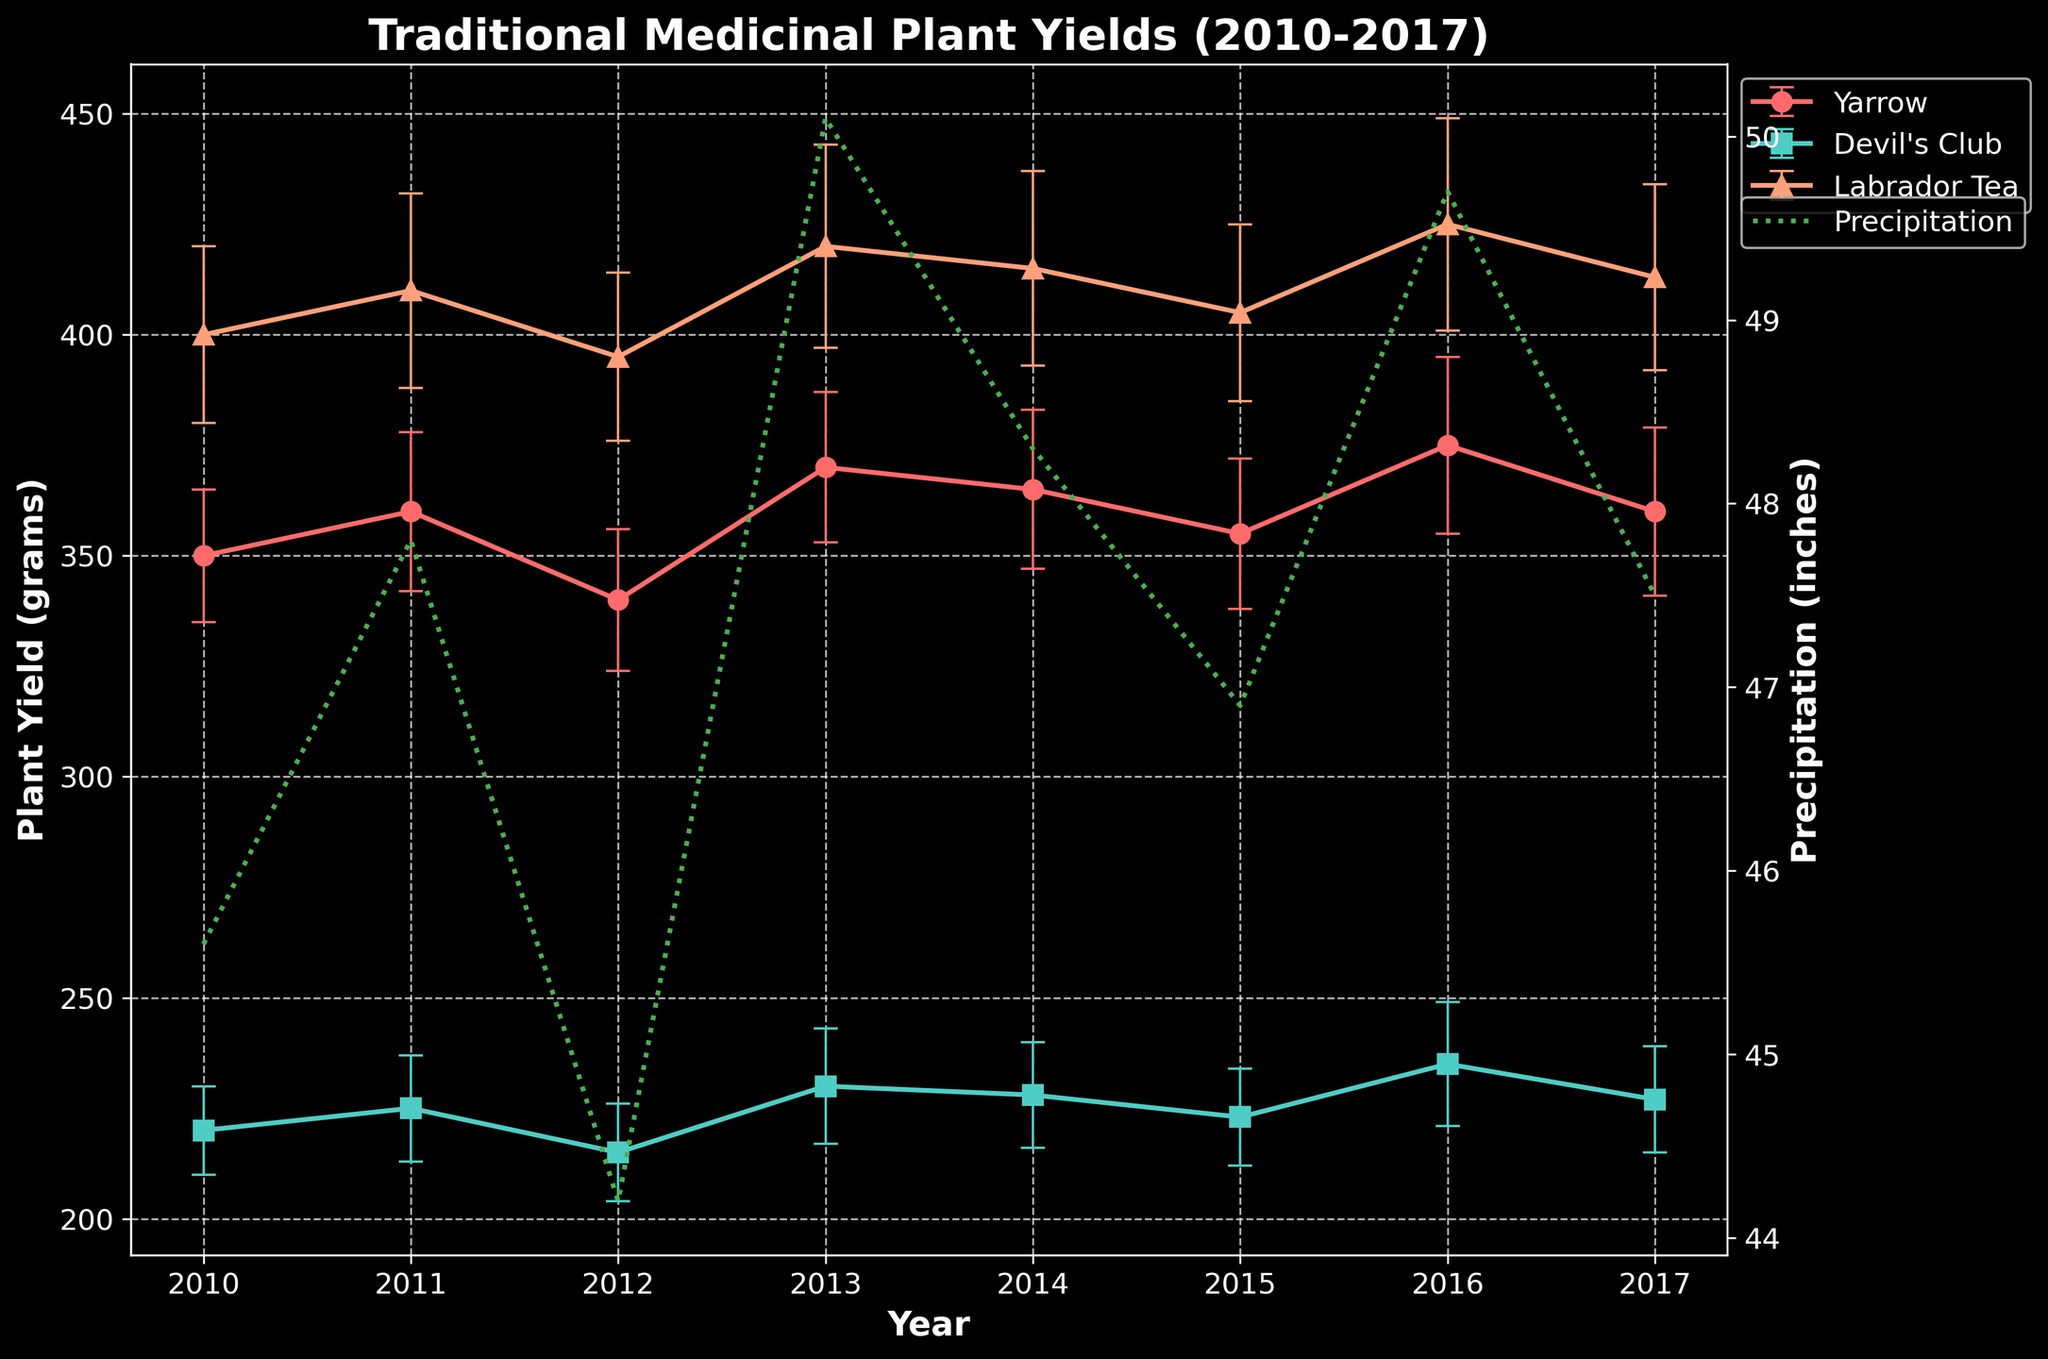What is the title of the figure? The title of the figure is typically located at the top. For our figure, it states: "Traditional Medicinal Plant Yields (2010-2017)".
Answer: Traditional Medicinal Plant Yields (2010-2017) Which medicinal plant had the highest yield in 2015? By observing the data points for the year 2015, we see the yields for each plant. Labrador Tea had the highest yield, marked by the highest point among all the plants in 2015.
Answer: Labrador Tea What is the general trend of Yarrow's yield from 2010 to 2017? Yarrow's yield is shown as data points connected by a line on the plot. Over the years from 2010 to 2017, the line gradually increases, indicating an increasing trend.
Answer: Increasing Which year had the highest annual precipitation, and how does it align with the yields of the plants? The green dashed line representing precipitation peaks in 2013. Observing the yields in 2013, we see relatively high yields for all plants.
Answer: 2013, High yields What is the average yield of Devil's Club across all years? Yields for Devil's Club from 2010 to 2017 are: 220, 225, 215, 230, 228, 223, 235, 227. Summing these yields: 1803, then dividing by 8 (number of years), gives the average. (1803/8 = 225.4)
Answer: 225.4 grams How did Labrador Tea's yield in 2017 compare to its yield in 2014? By looking at the plot for both years, we see that the yield in 2017 is slightly lower than in 2014.
Answer: Lower What error margin is shown for Yarrow in 2016? The error bar for Yarrow in 2016 can be observed, which indicates that the deviation around the yield value is ±20 grams.
Answer: ±20 grams Which plant showed the most variation in yield over the years? By observing the plot, the annual yield values for Labrador Tea show a wider range and larger changes than the others, indicating higher variation.
Answer: Labrador Tea What is the relationship between precipitation levels and the yield of Yarrow? Observing the plot together, Yarrow's yield tends to increase with an increase in precipitation levels, showing a positive relationship.
Answer: Positive relationship 